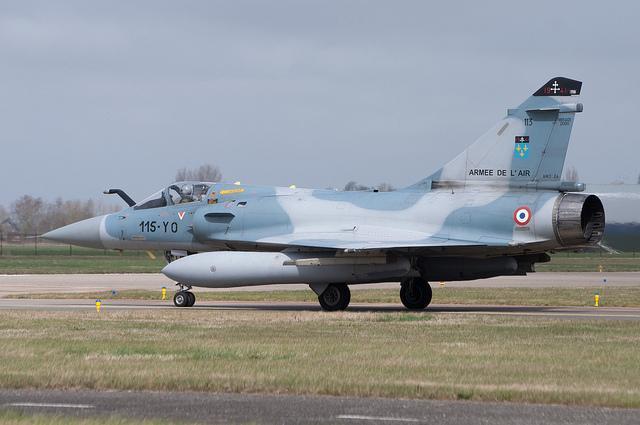How many airplanes are there?
Give a very brief answer. 1. 